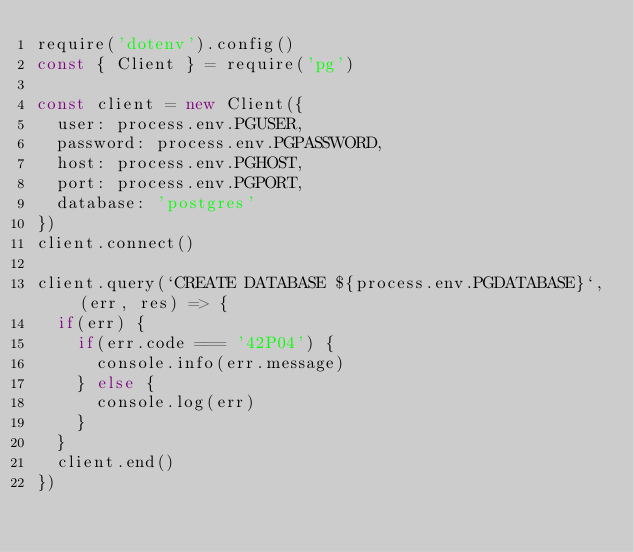<code> <loc_0><loc_0><loc_500><loc_500><_JavaScript_>require('dotenv').config()
const { Client } = require('pg')

const client = new Client({
  user: process.env.PGUSER,
  password: process.env.PGPASSWORD,
  host: process.env.PGHOST,
  port: process.env.PGPORT,
  database: 'postgres'
})
client.connect()

client.query(`CREATE DATABASE ${process.env.PGDATABASE}`, (err, res) => {
  if(err) {
    if(err.code === '42P04') {
      console.info(err.message) 
    } else {
      console.log(err)
    }
  }
  client.end()
})
</code> 